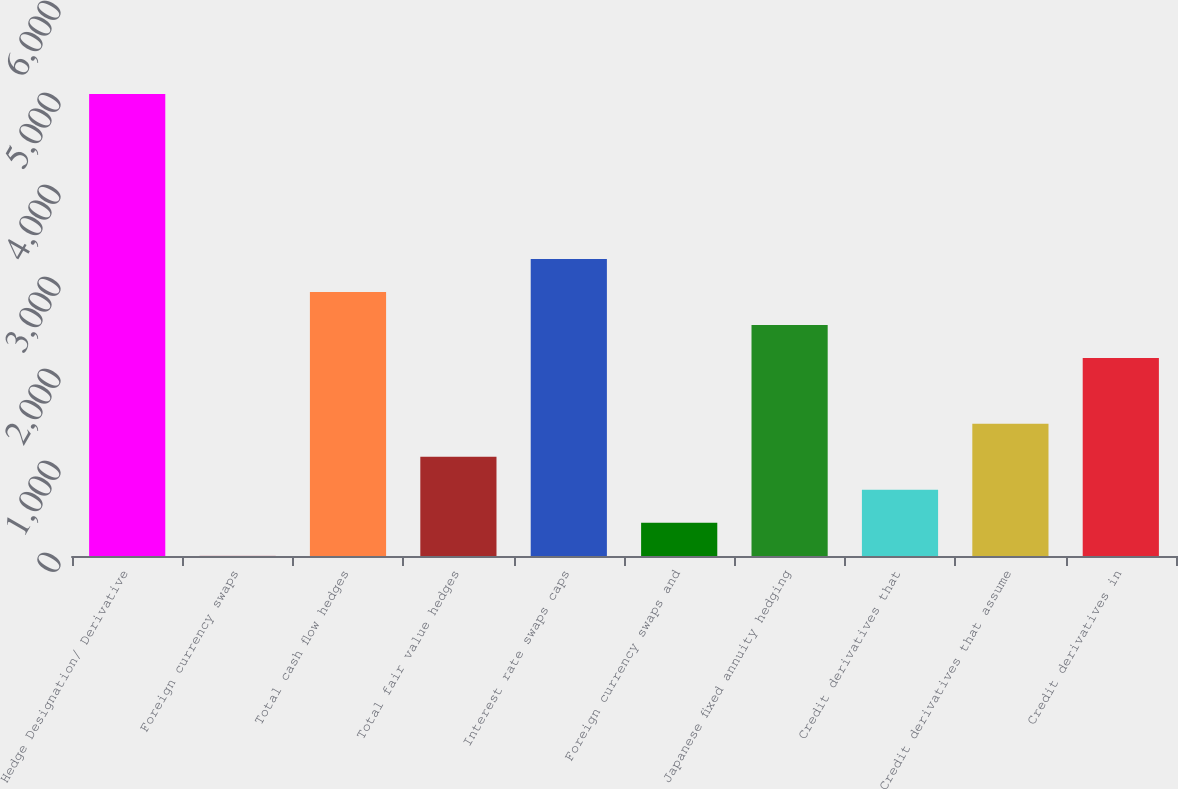<chart> <loc_0><loc_0><loc_500><loc_500><bar_chart><fcel>Hedge Designation/ Derivative<fcel>Foreign currency swaps<fcel>Total cash flow hedges<fcel>Total fair value hedges<fcel>Interest rate swaps caps<fcel>Foreign currency swaps and<fcel>Japanese fixed annuity hedging<fcel>Credit derivatives that<fcel>Credit derivatives that assume<fcel>Credit derivatives in<nl><fcel>5020.6<fcel>3<fcel>2870.2<fcel>1078.2<fcel>3228.6<fcel>361.4<fcel>2511.8<fcel>719.8<fcel>1436.6<fcel>2153.4<nl></chart> 